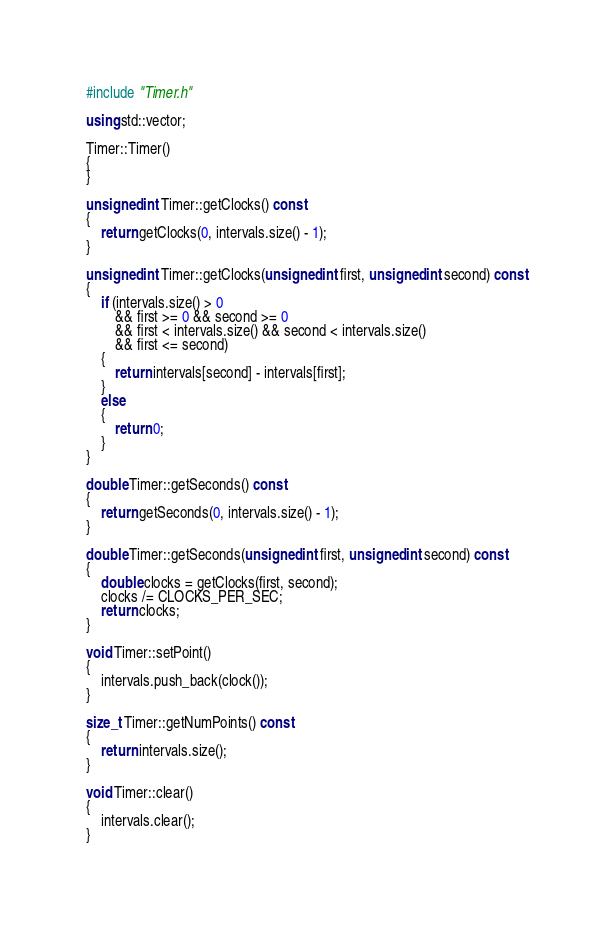<code> <loc_0><loc_0><loc_500><loc_500><_C++_>#include "Timer.h"

using std::vector;

Timer::Timer()
{
}

unsigned int Timer::getClocks() const
{
    return getClocks(0, intervals.size() - 1);
}

unsigned int Timer::getClocks(unsigned int first, unsigned int second) const
{
    if (intervals.size() > 0 
        && first >= 0 && second >= 0
        && first < intervals.size() && second < intervals.size()
        && first <= second)
    {
        return intervals[second] - intervals[first];
    }
    else
    {
        return 0;
    }
}

double Timer::getSeconds() const
{
    return getSeconds(0, intervals.size() - 1);
}

double Timer::getSeconds(unsigned int first, unsigned int second) const
{
    double clocks = getClocks(first, second);
    clocks /= CLOCKS_PER_SEC;
    return clocks;
}

void Timer::setPoint()
{
    intervals.push_back(clock());
}

size_t Timer::getNumPoints() const
{
    return intervals.size();
}

void Timer::clear()
{
    intervals.clear();
}
</code> 